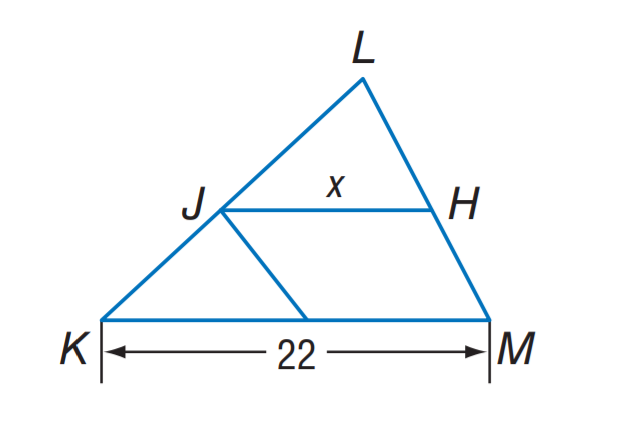Answer the mathemtical geometry problem and directly provide the correct option letter.
Question: J H is a midsegment of \triangle K L M. Find x.
Choices: A: 5 B: 10 C: 11 D: 22 C 